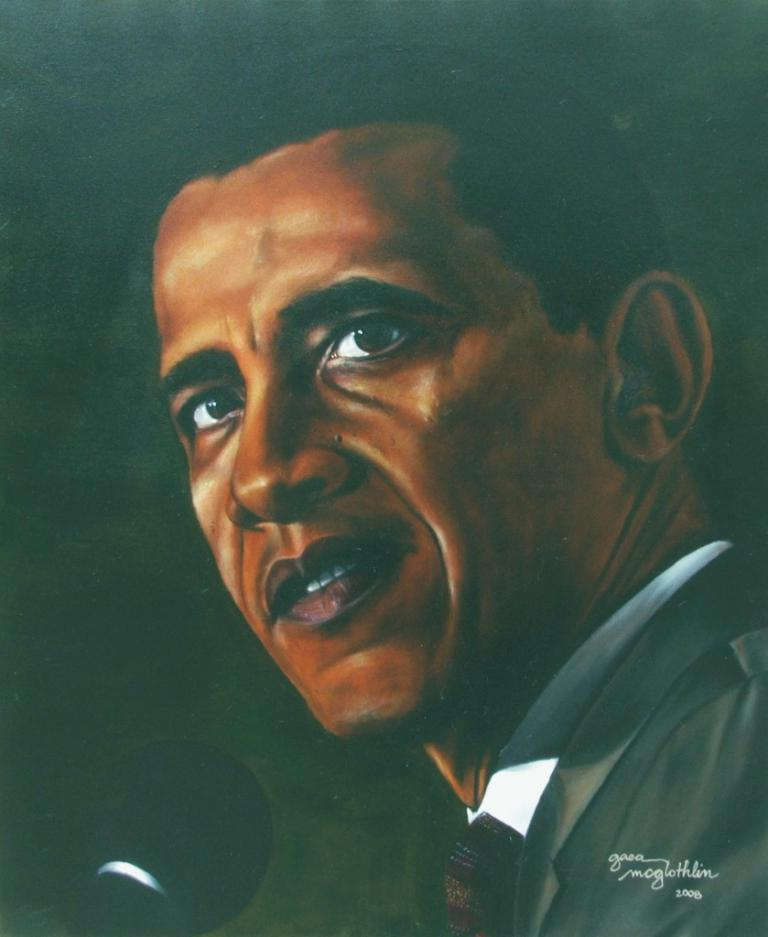What object is depicted in the painting? The painting contains a mic. What else can be seen on the painting besides the mic? There is text written on the painting. Who is the person in the painting? The person in the painting is Obama. What is Obama wearing in the painting? Obama is wearing a white shirt, a tie, and a coat. How many snakes are slithering around Obama's feet in the painting? There are no snakes present in the painting; it features Obama with a mic and text. What decision is Obama making in the painting? The painting does not depict Obama making a decision; it simply shows him with a mic and text. 